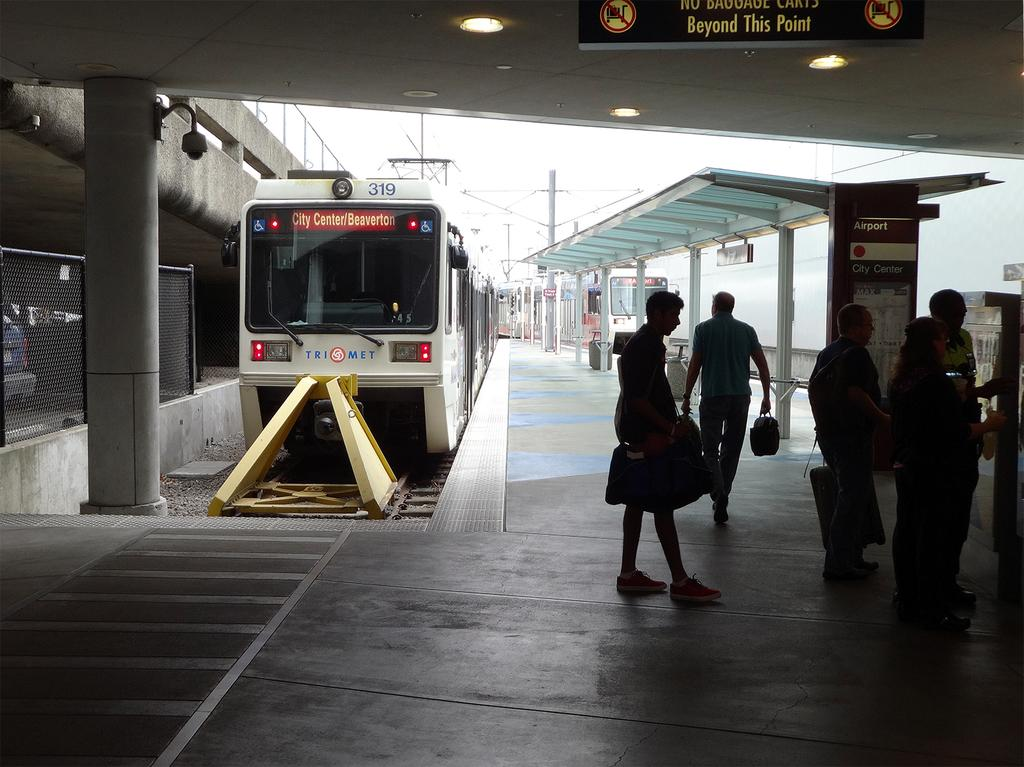<image>
Summarize the visual content of the image. a terminal with bus number 319  going to city center/ beaverton 